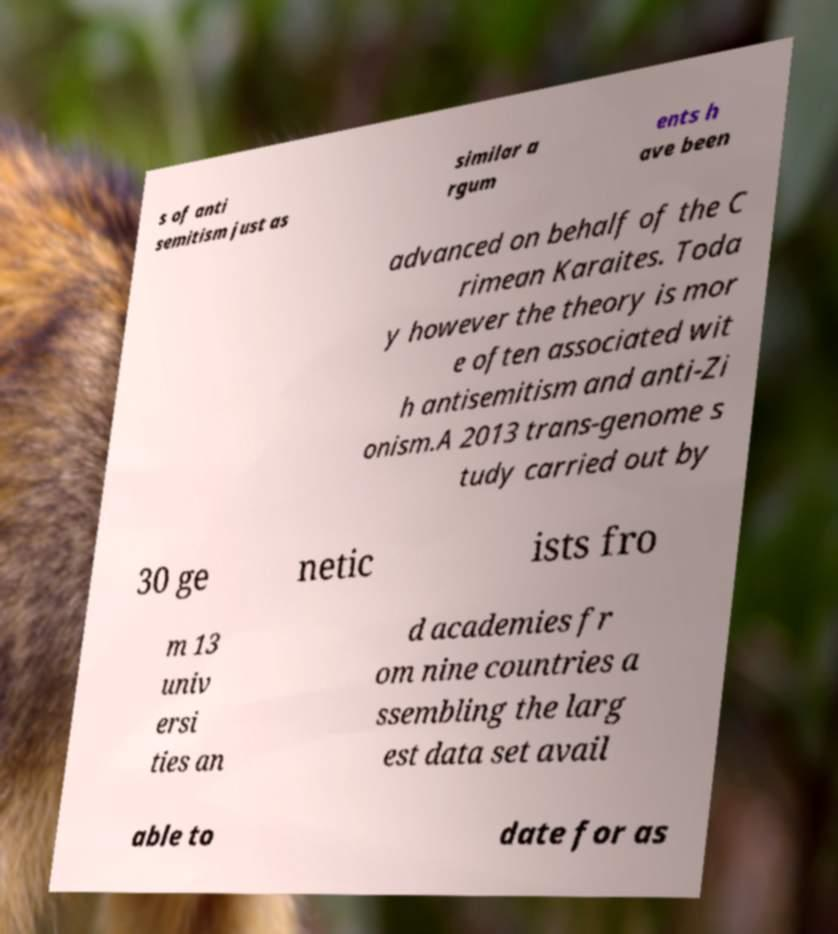There's text embedded in this image that I need extracted. Can you transcribe it verbatim? s of anti semitism just as similar a rgum ents h ave been advanced on behalf of the C rimean Karaites. Toda y however the theory is mor e often associated wit h antisemitism and anti-Zi onism.A 2013 trans-genome s tudy carried out by 30 ge netic ists fro m 13 univ ersi ties an d academies fr om nine countries a ssembling the larg est data set avail able to date for as 